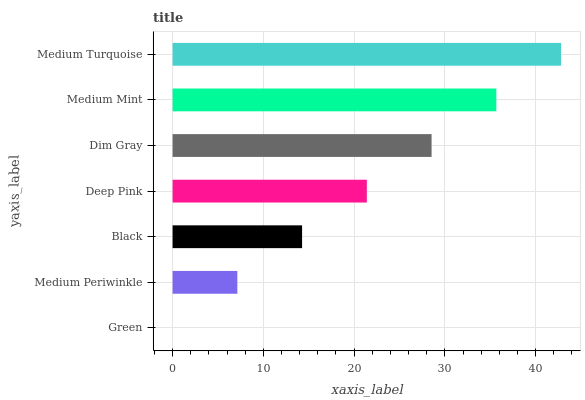Is Green the minimum?
Answer yes or no. Yes. Is Medium Turquoise the maximum?
Answer yes or no. Yes. Is Medium Periwinkle the minimum?
Answer yes or no. No. Is Medium Periwinkle the maximum?
Answer yes or no. No. Is Medium Periwinkle greater than Green?
Answer yes or no. Yes. Is Green less than Medium Periwinkle?
Answer yes or no. Yes. Is Green greater than Medium Periwinkle?
Answer yes or no. No. Is Medium Periwinkle less than Green?
Answer yes or no. No. Is Deep Pink the high median?
Answer yes or no. Yes. Is Deep Pink the low median?
Answer yes or no. Yes. Is Green the high median?
Answer yes or no. No. Is Dim Gray the low median?
Answer yes or no. No. 